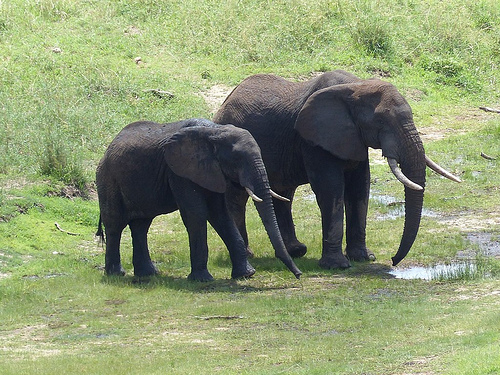What is the animal that is drinking from a puddle? The animal that is drinking from a puddle is an elephant. 